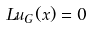Convert formula to latex. <formula><loc_0><loc_0><loc_500><loc_500>L u _ { G } ( x ) = 0</formula> 